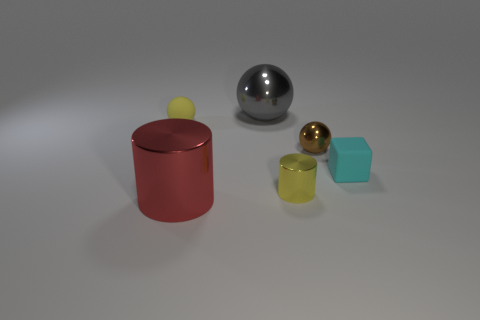Add 3 big cylinders. How many objects exist? 9 Subtract all blocks. How many objects are left? 5 Add 2 small objects. How many small objects exist? 6 Subtract 0 green cylinders. How many objects are left? 6 Subtract all large things. Subtract all spheres. How many objects are left? 1 Add 5 blocks. How many blocks are left? 6 